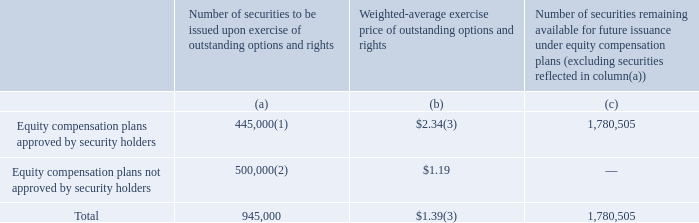Equity Compensation Plan Information
The following table summarizes share and exercise price information for our equity compensation plans as of December 31, 2019.
(1) Includes 105,000 shares of our common stock issuable upon exercise of outstanding stock options and 340,000 shares issuable upon vesting of outstanding restricted stock units.
(2) Represents an individual option grant to our Chairman and Chief Executive Officer outside of, and prior to the establishment of, the 2013 Stock Incentive Plan in October 2013 referred to in the above table. The option agreement pertaining to such option grant contain customary anti-dilution provisions.
(3) Does not take into account outstanding restricted stock units as these awards have no exercise price.
Our 2013 Stock Incentive Plan (“2013 Plan”) provides for the grant of any or all of the following types of awards: (a) stock options, (b) restricted stock, (c) deferred stock, (d) stock appreciation rights, and (e) other stock-based awards including restricted stock units. Awards under the 2013 Plan may be granted singly, in combination, or in tandem. Subject to standard anti-dilution adjustments as provided in the 2013 Plan, the 2013 Plan provides for an aggregate of 2,600,000 shares of our common stock to be available for distribution pursuant to the 2013 Plan. The Compensation Committee (or the Board of Directors) will generally have the authority to administer the 2013 Plan, determine participants who will be granted awards under the 2013 Plan, the size and types of awards, the terms and conditions of awards and the form and content of the award agreements representing awards. Awards under the 2013 Plan may be granted to our employees, directors and consultants. As of December 31, 2019, there were options to purchase an aggregate of 605,000 shares of common stock outstanding and 340,000 shares issuable upon vesting of outstanding restricted stock units granted under the 2013 Plan, and a balance of 1,780,505 shares of common stock are reserved for issuance under the 2013 Plan.
Who would have benefited from the equity compensation plans not approved by security holders? Chairman and chief executive officer. Which parties may be granted Awards under the 2013 plan? Awards under the 2013 plan may be granted to our employees, directors and consultants. What are the types of awards that may be granted under the 2013 Stock Incentive Plan? (a) stock options, (b) restricted stock, (c) deferred stock, (d) stock appreciation rights, and (e) other stock-based awards including restricted stock units. What is the proportion of equity compensation plans approved by security holders to the total number of securities to be issued upon exercise of outstanding options and rights? 445,000/945,000
Answer: 0.47. What % of equity compensation plans that are approved are shares of common stock issuable upon exercise of outstanding stock options?
Answer scale should be: percent. 105,000/445,000
Answer: 23.6. What % of equity compensation plans that are approved are shares issuable upon vesting of outstanding restricted stock units?
Answer scale should be: percent. 340,000/445,000
Answer: 76.4. 